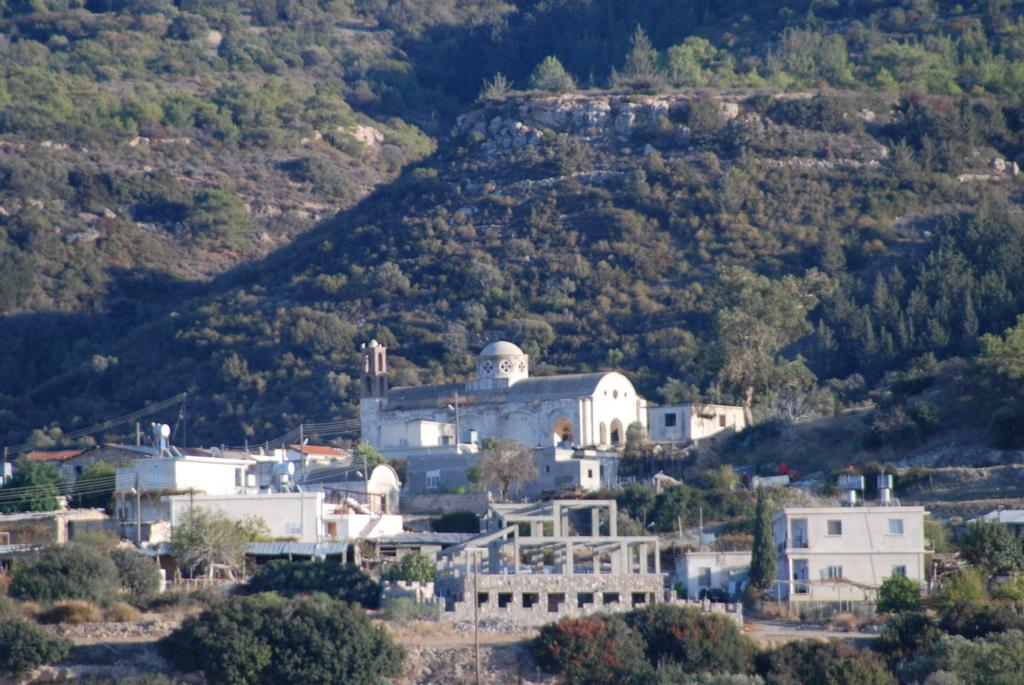What type of vegetation is visible in the front of the image? There are trees in the front of the image. What type of structures are located in the center of the image? There are buildings in the center of the image. What type of vegetation is visible in the background of the image? There are trees and plants in the background of the image. How much profit does the beggar make from the jam in the image? There is no beggar or jam present in the image, so it is not possible to determine any profit. 